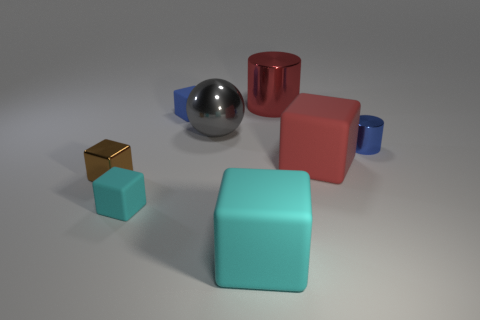Subtract all brown cubes. How many cubes are left? 4 Subtract all large cyan matte cubes. How many cubes are left? 4 Add 1 small brown cubes. How many objects exist? 9 Subtract all gray blocks. Subtract all red cylinders. How many blocks are left? 5 Subtract all blocks. How many objects are left? 3 Add 1 tiny brown metallic cylinders. How many tiny brown metallic cylinders exist? 1 Subtract 0 green cylinders. How many objects are left? 8 Subtract all small cyan shiny spheres. Subtract all small rubber objects. How many objects are left? 6 Add 2 metal cylinders. How many metal cylinders are left? 4 